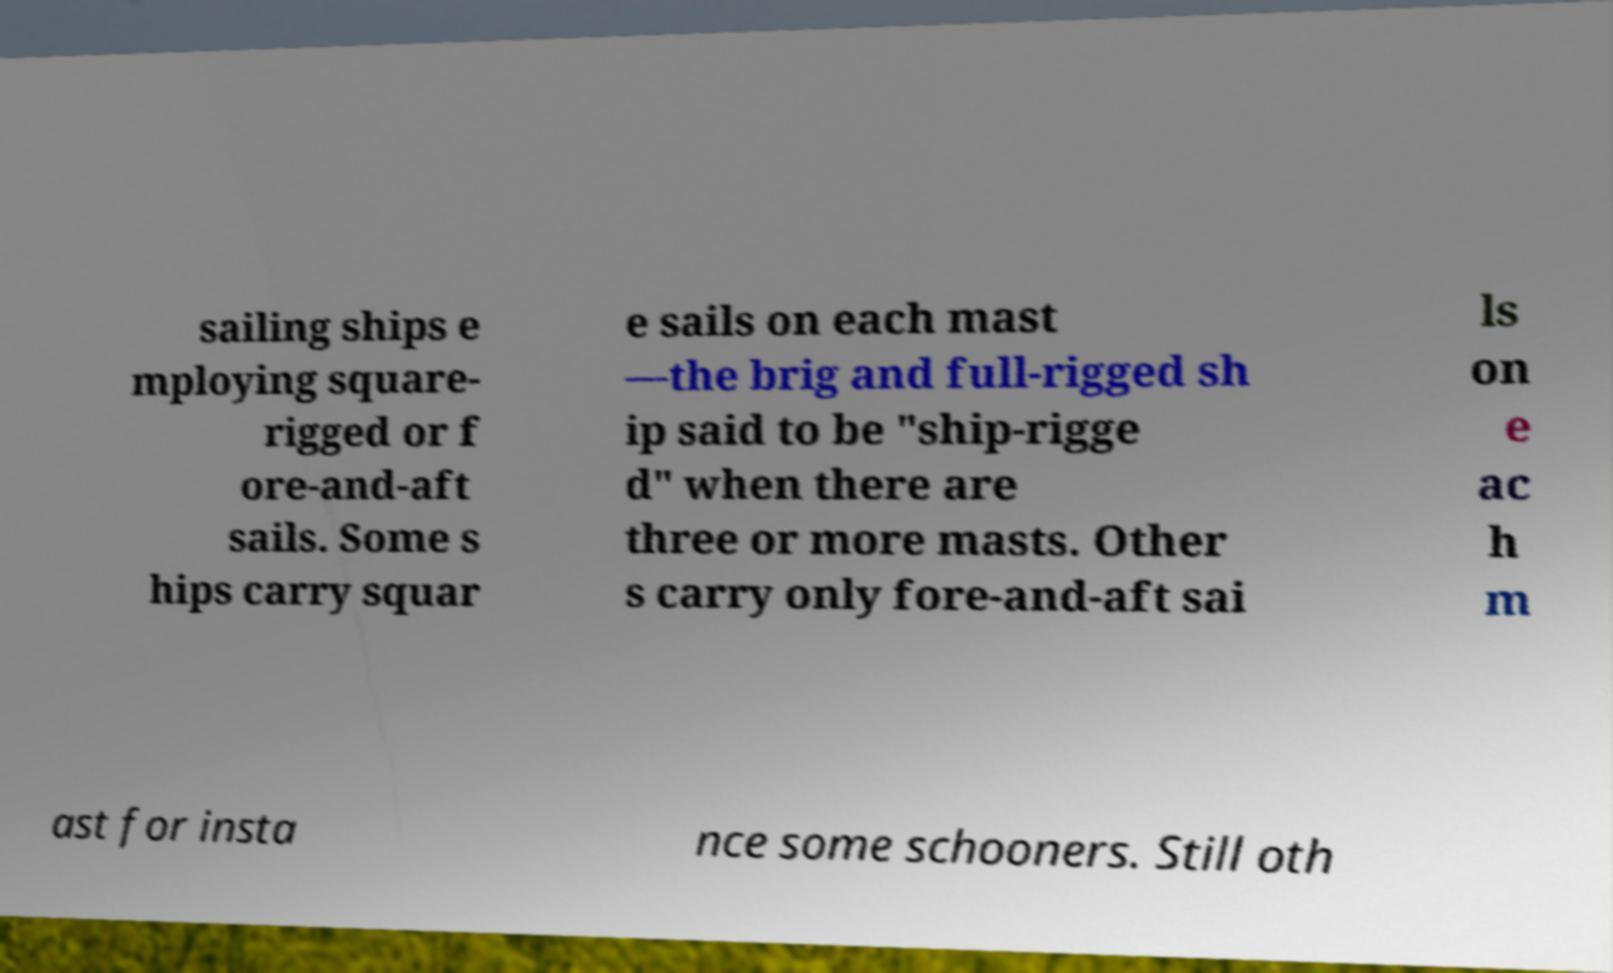I need the written content from this picture converted into text. Can you do that? sailing ships e mploying square- rigged or f ore-and-aft sails. Some s hips carry squar e sails on each mast —the brig and full-rigged sh ip said to be "ship-rigge d" when there are three or more masts. Other s carry only fore-and-aft sai ls on e ac h m ast for insta nce some schooners. Still oth 